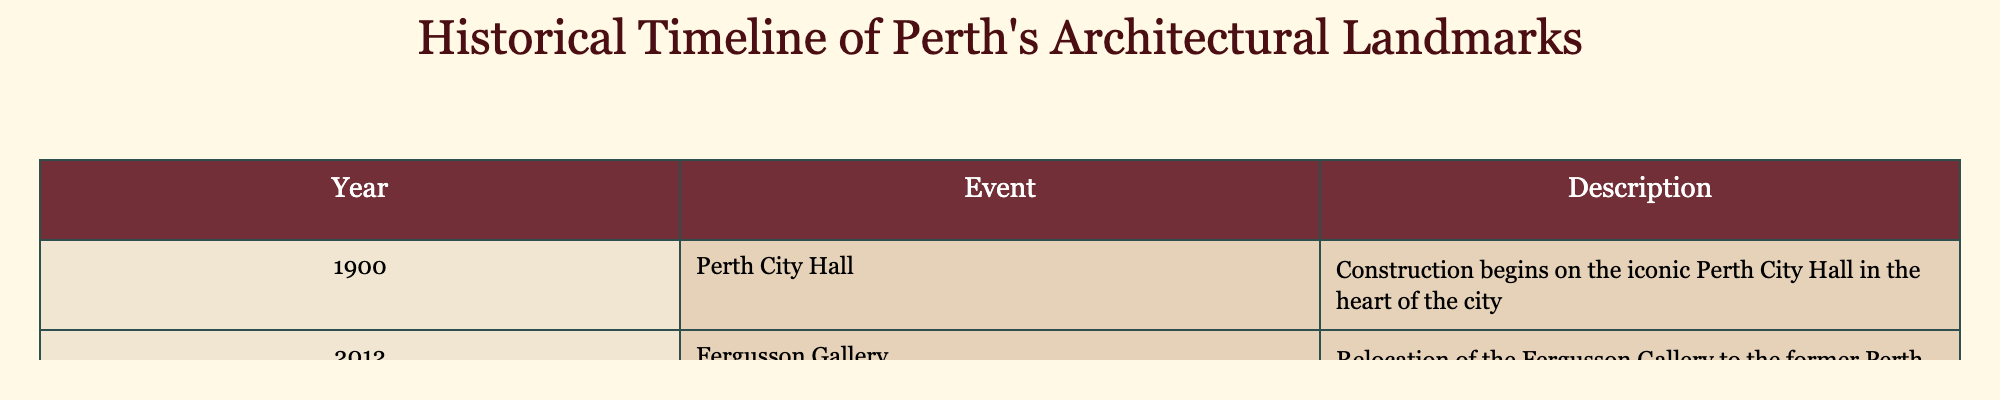What year did the construction of Perth City Hall begin? The table lists the year and event corresponding to each architectural landmark. For Perth City Hall, it indicates that construction began in 1900.
Answer: 1900 What landmark was relocated in 2012? By examining the events from the table, it specifies that the Fergusson Gallery was relocated to the former Perth Waterworks building in 2012.
Answer: Fergusson Gallery Is there a landmark from the 20th century mentioned in the table? The table shows that Perth City Hall, constructed starting in 1900, is from the 20th century, making the statement true.
Answer: Yes How many architectural events are listed in the table? The table contains two rows of architectural events, one for each landmark. Therefore, the total number of events is 2.
Answer: 2 What was the purpose of the building that housed Fergusson Gallery after its relocation? Looking at the table, it states that the Fergusson Gallery was relocated to the former Perth Waterworks building. Therefore, the previous use of the building was for waterworks, and now it serves as a gallery.
Answer: To serve as an art gallery Which landmark mentioned in the table is associated with the year 2012? The event listed for the year 2012 is the relocation of the Fergusson Gallery; thus, it can be asked which landmark is associated with it.
Answer: Fergusson Gallery Was there any architectural landmark constructed between 1900 and 2000 according to the table? The only mentioned construction in the table is for Perth City Hall in 1900, which falls within the specified range, confirming that there is indeed a landmark from that period.
Answer: Yes What is the difference in years between the construction of Perth City Hall and the relocation of Fergusson Gallery? The year for Perth City Hall is 1900, and for the Fergusson Gallery, it is 2012. To find the difference: 2012 - 1900 = 112 years.
Answer: 112 years 